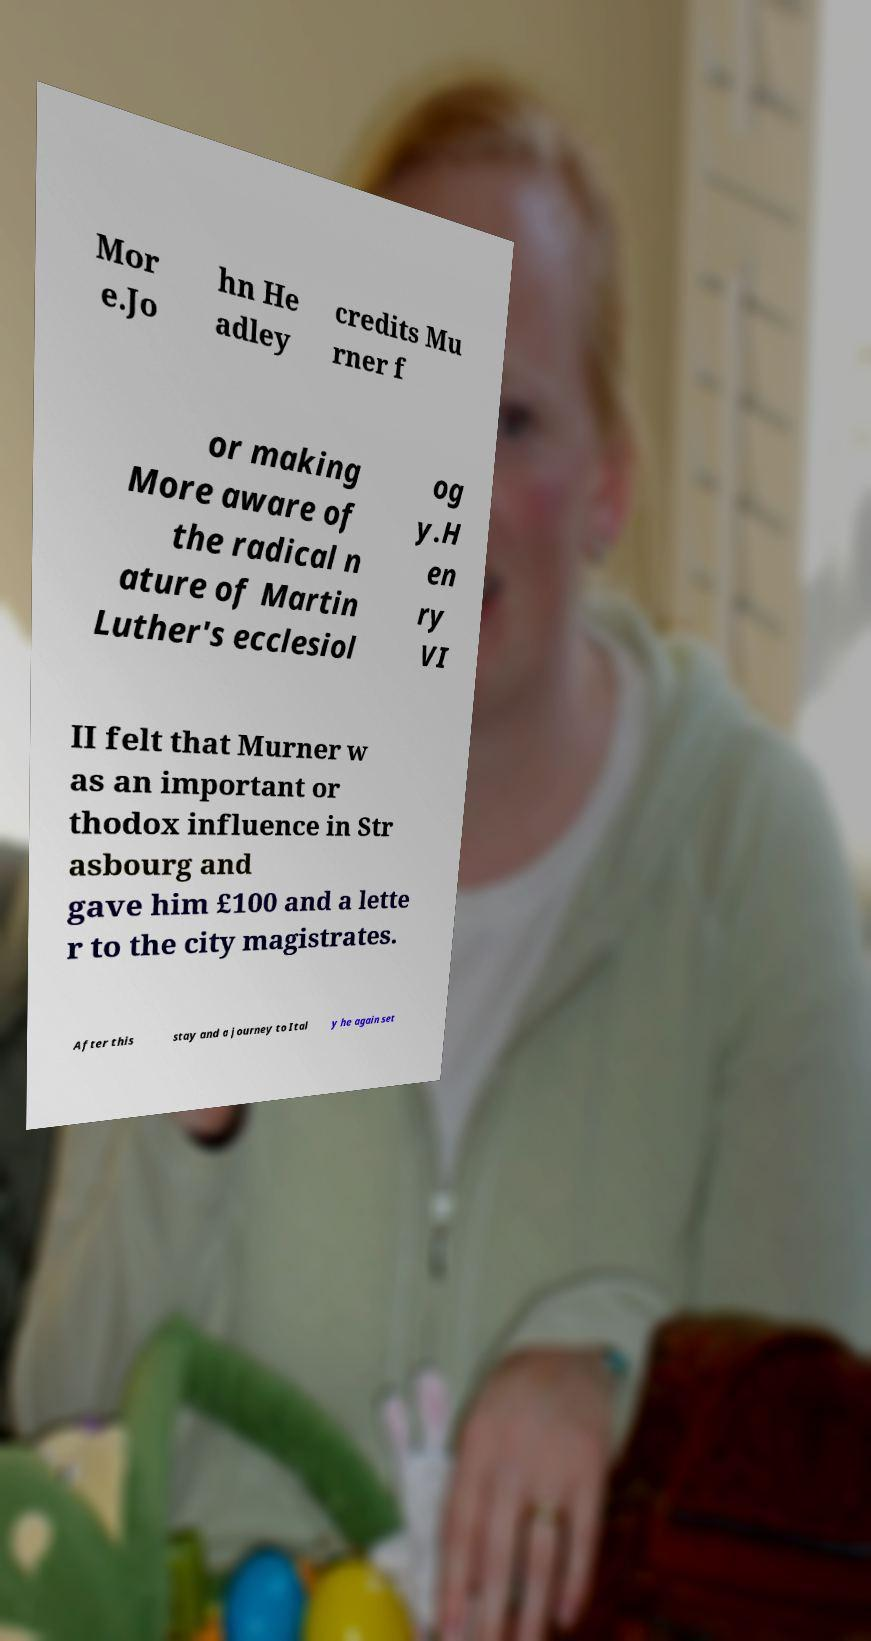Could you assist in decoding the text presented in this image and type it out clearly? Mor e.Jo hn He adley credits Mu rner f or making More aware of the radical n ature of Martin Luther's ecclesiol og y.H en ry VI II felt that Murner w as an important or thodox influence in Str asbourg and gave him £100 and a lette r to the city magistrates. After this stay and a journey to Ital y he again set 